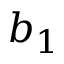Convert formula to latex. <formula><loc_0><loc_0><loc_500><loc_500>b _ { 1 }</formula> 